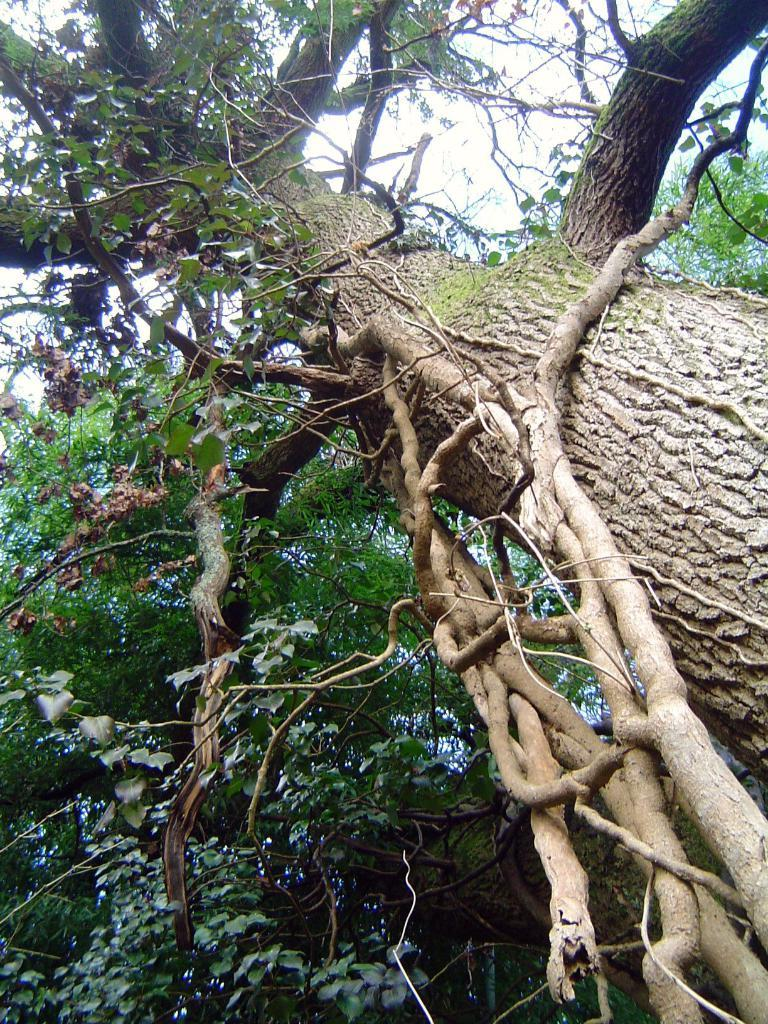What type of vegetation can be seen in the image? There are trees in the image. Can you describe the trees in the image? The provided facts do not include specific details about the trees, so we cannot describe them further. Where is the father standing in the image? There is no father present in the image; it only features trees. How many pigs can be seen playing in the harbor in the image? There is no harbor or pigs present in the image; it only features trees. 